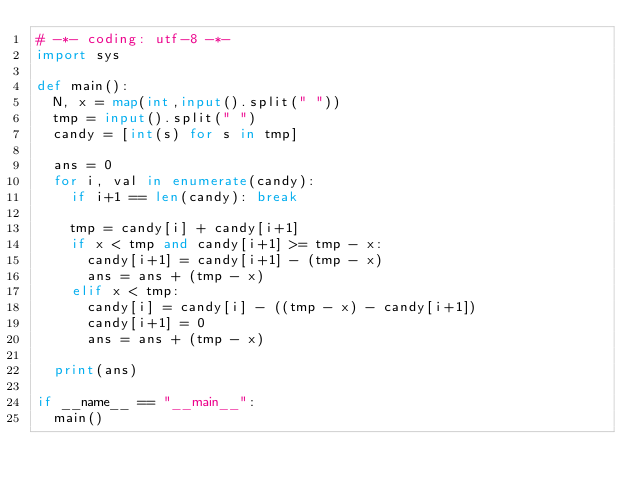<code> <loc_0><loc_0><loc_500><loc_500><_Python_># -*- coding: utf-8 -*-
import sys

def main():
	N, x = map(int,input().split(" "))
	tmp = input().split(" ")
	candy = [int(s) for s in tmp]
	
	ans = 0
	for i, val in enumerate(candy):
		if i+1 == len(candy): break
		
		tmp = candy[i] + candy[i+1]
		if x < tmp and candy[i+1] >= tmp - x:
			candy[i+1] = candy[i+1] - (tmp - x)
			ans = ans + (tmp - x)
		elif x < tmp:
			candy[i] = candy[i] - ((tmp - x) - candy[i+1])
			candy[i+1] = 0
			ans = ans + (tmp - x)
	
	print(ans)

if __name__ == "__main__":
	main()
</code> 